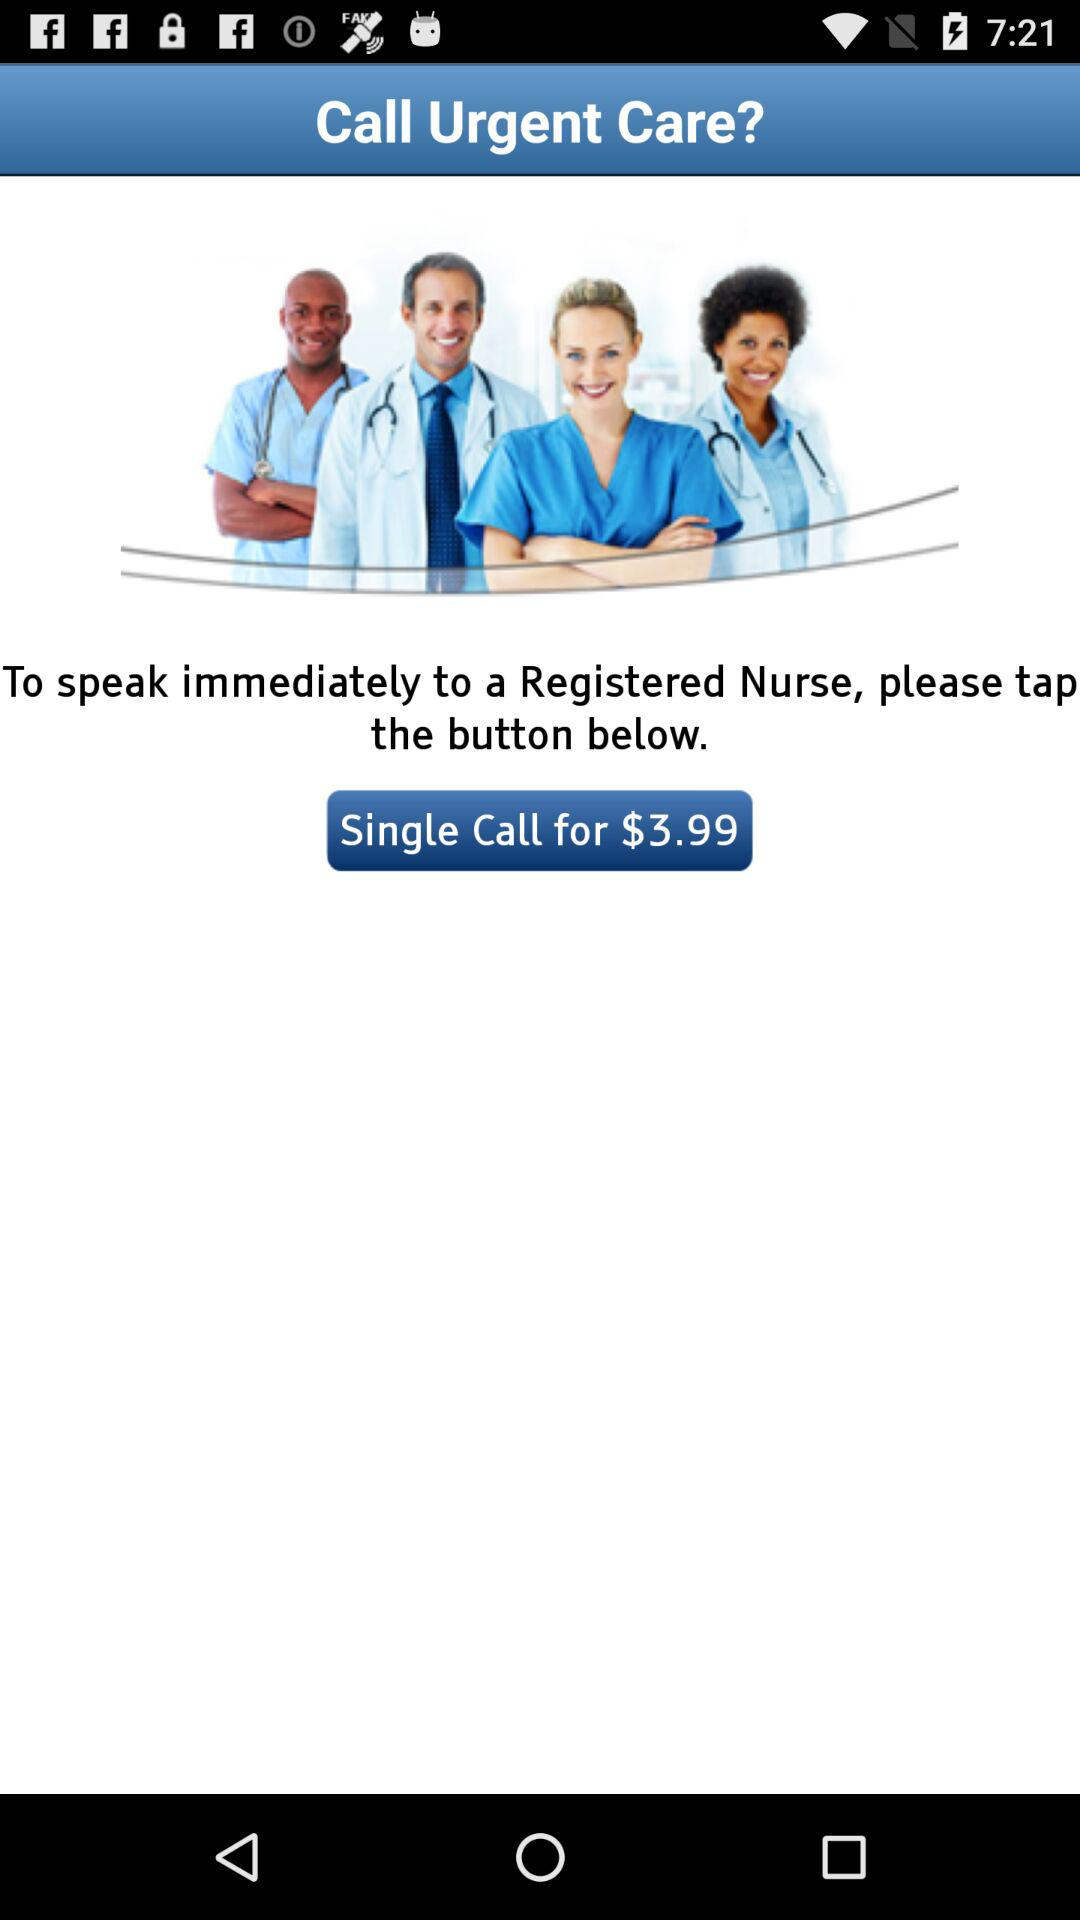What is the price of a single call? The price is $3.99. 